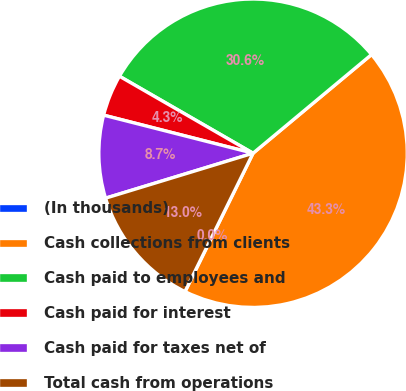Convert chart. <chart><loc_0><loc_0><loc_500><loc_500><pie_chart><fcel>(In thousands)<fcel>Cash collections from clients<fcel>Cash paid to employees and<fcel>Cash paid for interest<fcel>Cash paid for taxes net of<fcel>Total cash from operations<nl><fcel>0.02%<fcel>43.32%<fcel>30.63%<fcel>4.35%<fcel>8.68%<fcel>13.01%<nl></chart> 